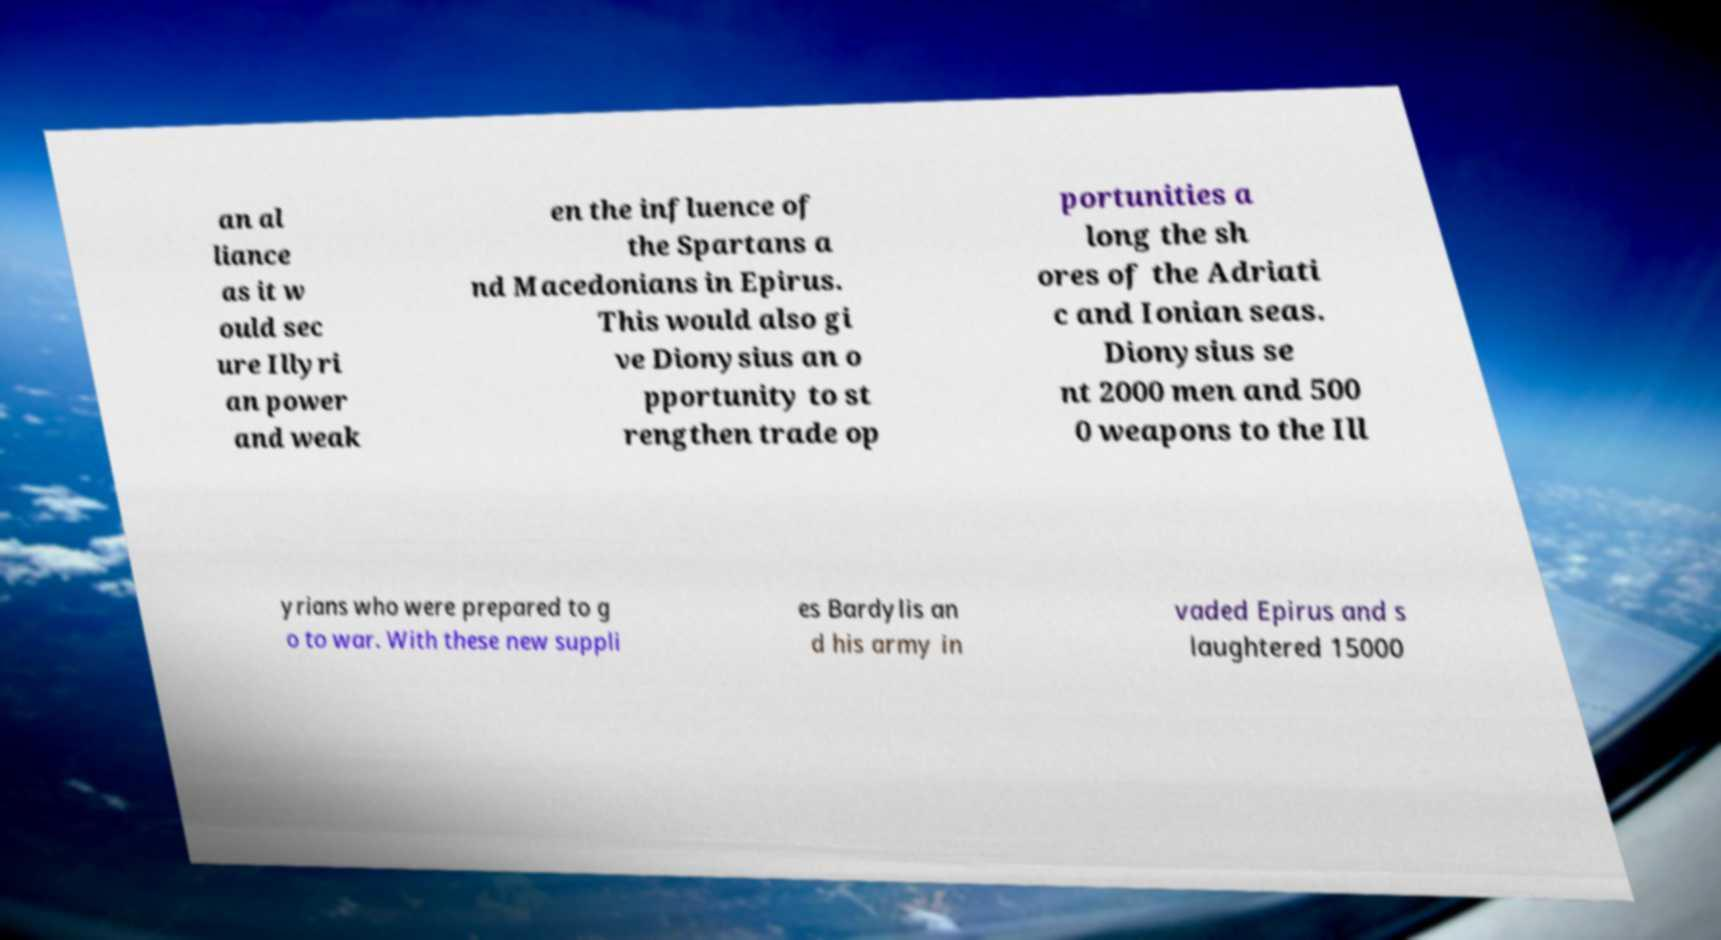Could you extract and type out the text from this image? an al liance as it w ould sec ure Illyri an power and weak en the influence of the Spartans a nd Macedonians in Epirus. This would also gi ve Dionysius an o pportunity to st rengthen trade op portunities a long the sh ores of the Adriati c and Ionian seas. Dionysius se nt 2000 men and 500 0 weapons to the Ill yrians who were prepared to g o to war. With these new suppli es Bardylis an d his army in vaded Epirus and s laughtered 15000 